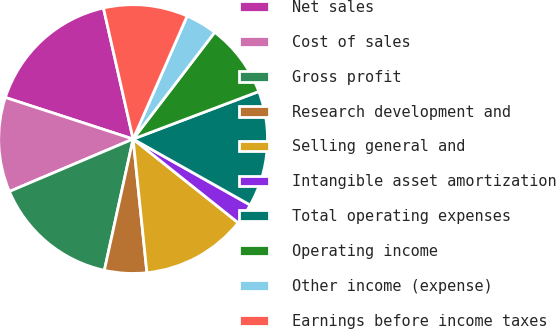<chart> <loc_0><loc_0><loc_500><loc_500><pie_chart><fcel>Net sales<fcel>Cost of sales<fcel>Gross profit<fcel>Research development and<fcel>Selling general and<fcel>Intangible asset amortization<fcel>Total operating expenses<fcel>Operating income<fcel>Other income (expense)<fcel>Earnings before income taxes<nl><fcel>16.45%<fcel>11.39%<fcel>15.19%<fcel>5.07%<fcel>12.66%<fcel>2.54%<fcel>13.92%<fcel>8.86%<fcel>3.8%<fcel>10.13%<nl></chart> 